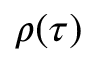<formula> <loc_0><loc_0><loc_500><loc_500>\rho ( \tau )</formula> 